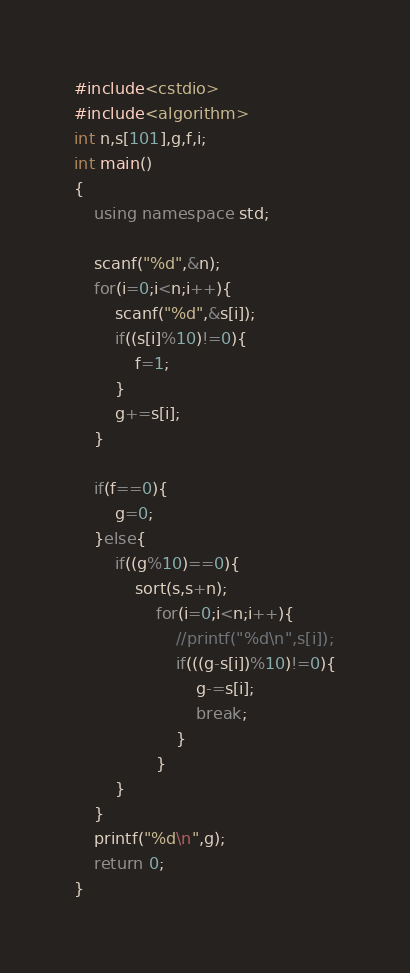Convert code to text. <code><loc_0><loc_0><loc_500><loc_500><_C++_>#include<cstdio>
#include<algorithm>
int n,s[101],g,f,i;
int main()
{
	using namespace std;
	
	scanf("%d",&n);
	for(i=0;i<n;i++){
		scanf("%d",&s[i]);
		if((s[i]%10)!=0){
			f=1;
		}
		g+=s[i];
	}
	
	if(f==0){
		g=0;
	}else{
		if((g%10)==0){
			sort(s,s+n);
				for(i=0;i<n;i++){
					//printf("%d\n",s[i]);
					if(((g-s[i])%10)!=0){
						g-=s[i];
						break;
					}
				}
		}
	}
	printf("%d\n",g);
	return 0;
}</code> 